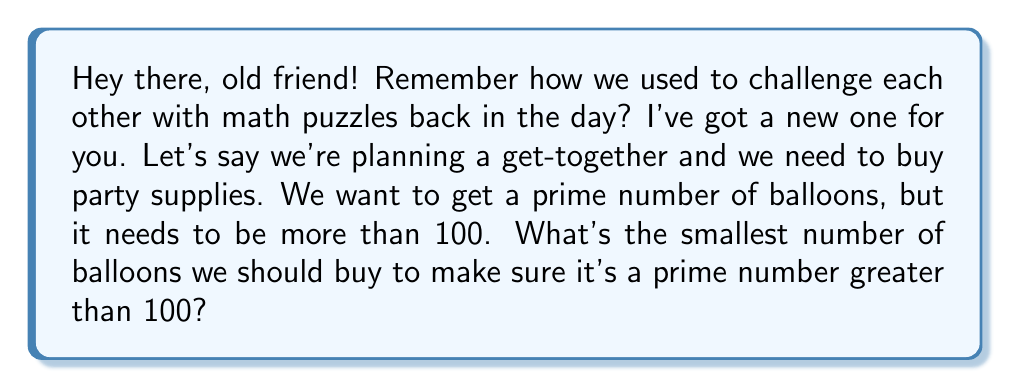Provide a solution to this math problem. To solve this problem, we need to find the smallest prime number greater than 100. Let's approach this step-by-step:

1) First, let's start with 101 and check if it's prime.

2) To check if a number $n$ is prime, we only need to check for divisibility up to $\sqrt{n}$. For 101, $\sqrt{101} \approx 10.05$, so we only need to check divisibility by primes up to 10.

3) Let's check divisibility by 2, 3, 5, and 7:

   101 ÷ 2 = 50 remainder 1
   101 ÷ 3 = 33 remainder 2
   101 ÷ 5 = 20 remainder 1
   101 ÷ 7 = 14 remainder 3

4) Since 101 is not divisible by any of these primes, it is itself a prime number.

5) Therefore, 101 is the smallest prime number greater than 100.

In the context of our party planning, this means we should buy 101 balloons to have a prime number of balloons greater than 100.
Answer: 101 